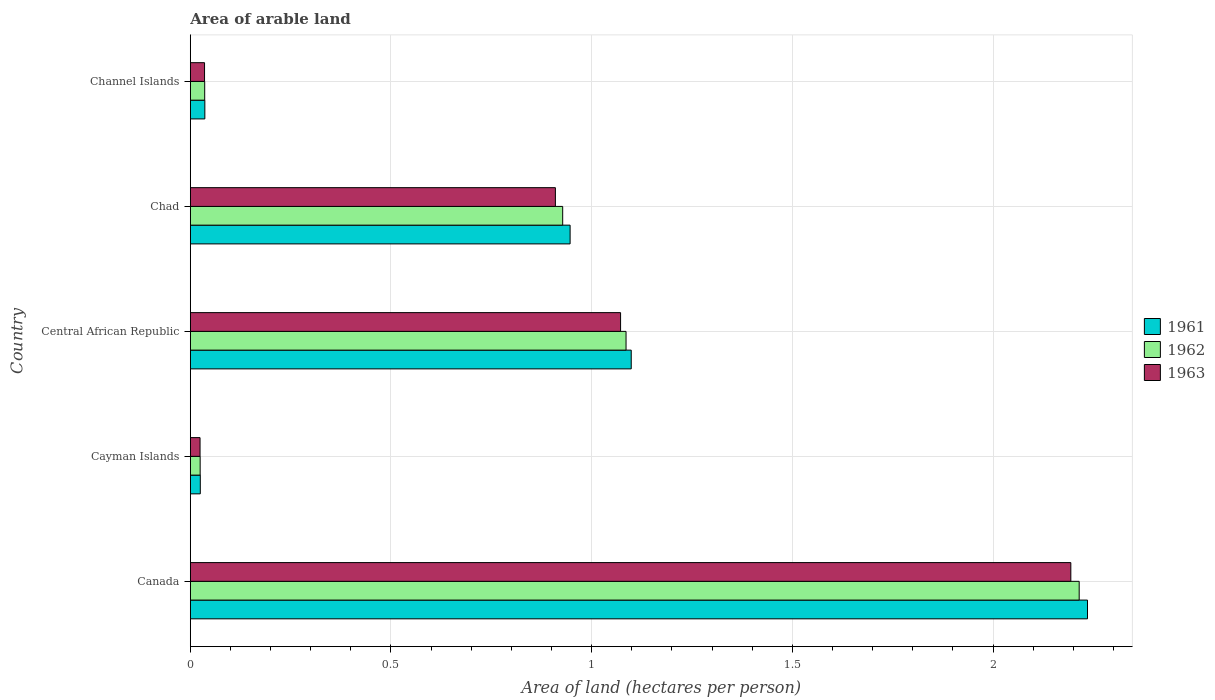Are the number of bars per tick equal to the number of legend labels?
Give a very brief answer. Yes. What is the label of the 4th group of bars from the top?
Your response must be concise. Cayman Islands. What is the total arable land in 1962 in Canada?
Provide a succinct answer. 2.21. Across all countries, what is the maximum total arable land in 1961?
Your answer should be very brief. 2.24. Across all countries, what is the minimum total arable land in 1962?
Your response must be concise. 0.02. In which country was the total arable land in 1962 minimum?
Ensure brevity in your answer.  Cayman Islands. What is the total total arable land in 1962 in the graph?
Provide a succinct answer. 4.29. What is the difference between the total arable land in 1961 in Canada and that in Central African Republic?
Provide a short and direct response. 1.14. What is the difference between the total arable land in 1962 in Central African Republic and the total arable land in 1963 in Canada?
Give a very brief answer. -1.11. What is the average total arable land in 1961 per country?
Make the answer very short. 0.87. What is the difference between the total arable land in 1961 and total arable land in 1962 in Channel Islands?
Your answer should be very brief. 0. In how many countries, is the total arable land in 1961 greater than 1.2 hectares per person?
Ensure brevity in your answer.  1. What is the ratio of the total arable land in 1963 in Cayman Islands to that in Chad?
Your answer should be compact. 0.03. Is the difference between the total arable land in 1961 in Cayman Islands and Channel Islands greater than the difference between the total arable land in 1962 in Cayman Islands and Channel Islands?
Your answer should be very brief. Yes. What is the difference between the highest and the second highest total arable land in 1962?
Give a very brief answer. 1.13. What is the difference between the highest and the lowest total arable land in 1962?
Offer a very short reply. 2.19. How many bars are there?
Your answer should be very brief. 15. What is the difference between two consecutive major ticks on the X-axis?
Keep it short and to the point. 0.5. Are the values on the major ticks of X-axis written in scientific E-notation?
Provide a succinct answer. No. Does the graph contain any zero values?
Your answer should be compact. No. Where does the legend appear in the graph?
Provide a short and direct response. Center right. How many legend labels are there?
Offer a very short reply. 3. What is the title of the graph?
Offer a terse response. Area of arable land. Does "1966" appear as one of the legend labels in the graph?
Give a very brief answer. No. What is the label or title of the X-axis?
Offer a terse response. Area of land (hectares per person). What is the Area of land (hectares per person) of 1961 in Canada?
Give a very brief answer. 2.24. What is the Area of land (hectares per person) in 1962 in Canada?
Your response must be concise. 2.21. What is the Area of land (hectares per person) in 1963 in Canada?
Make the answer very short. 2.19. What is the Area of land (hectares per person) of 1961 in Cayman Islands?
Offer a very short reply. 0.02. What is the Area of land (hectares per person) of 1962 in Cayman Islands?
Offer a very short reply. 0.02. What is the Area of land (hectares per person) in 1963 in Cayman Islands?
Make the answer very short. 0.02. What is the Area of land (hectares per person) in 1961 in Central African Republic?
Your answer should be very brief. 1.1. What is the Area of land (hectares per person) of 1962 in Central African Republic?
Ensure brevity in your answer.  1.09. What is the Area of land (hectares per person) of 1963 in Central African Republic?
Ensure brevity in your answer.  1.07. What is the Area of land (hectares per person) of 1961 in Chad?
Your response must be concise. 0.95. What is the Area of land (hectares per person) of 1962 in Chad?
Your response must be concise. 0.93. What is the Area of land (hectares per person) in 1963 in Chad?
Your response must be concise. 0.91. What is the Area of land (hectares per person) in 1961 in Channel Islands?
Keep it short and to the point. 0.04. What is the Area of land (hectares per person) in 1962 in Channel Islands?
Make the answer very short. 0.04. What is the Area of land (hectares per person) of 1963 in Channel Islands?
Your answer should be compact. 0.04. Across all countries, what is the maximum Area of land (hectares per person) in 1961?
Make the answer very short. 2.24. Across all countries, what is the maximum Area of land (hectares per person) of 1962?
Offer a terse response. 2.21. Across all countries, what is the maximum Area of land (hectares per person) of 1963?
Your answer should be compact. 2.19. Across all countries, what is the minimum Area of land (hectares per person) in 1961?
Make the answer very short. 0.02. Across all countries, what is the minimum Area of land (hectares per person) in 1962?
Your response must be concise. 0.02. Across all countries, what is the minimum Area of land (hectares per person) of 1963?
Offer a terse response. 0.02. What is the total Area of land (hectares per person) in 1961 in the graph?
Your response must be concise. 4.34. What is the total Area of land (hectares per person) in 1962 in the graph?
Ensure brevity in your answer.  4.29. What is the total Area of land (hectares per person) of 1963 in the graph?
Ensure brevity in your answer.  4.24. What is the difference between the Area of land (hectares per person) in 1961 in Canada and that in Cayman Islands?
Make the answer very short. 2.21. What is the difference between the Area of land (hectares per person) of 1962 in Canada and that in Cayman Islands?
Your answer should be compact. 2.19. What is the difference between the Area of land (hectares per person) in 1963 in Canada and that in Cayman Islands?
Offer a very short reply. 2.17. What is the difference between the Area of land (hectares per person) of 1961 in Canada and that in Central African Republic?
Keep it short and to the point. 1.14. What is the difference between the Area of land (hectares per person) of 1962 in Canada and that in Central African Republic?
Give a very brief answer. 1.13. What is the difference between the Area of land (hectares per person) of 1963 in Canada and that in Central African Republic?
Keep it short and to the point. 1.12. What is the difference between the Area of land (hectares per person) in 1961 in Canada and that in Chad?
Give a very brief answer. 1.29. What is the difference between the Area of land (hectares per person) in 1962 in Canada and that in Chad?
Offer a very short reply. 1.29. What is the difference between the Area of land (hectares per person) in 1963 in Canada and that in Chad?
Keep it short and to the point. 1.28. What is the difference between the Area of land (hectares per person) of 1961 in Canada and that in Channel Islands?
Provide a succinct answer. 2.2. What is the difference between the Area of land (hectares per person) in 1962 in Canada and that in Channel Islands?
Your response must be concise. 2.18. What is the difference between the Area of land (hectares per person) of 1963 in Canada and that in Channel Islands?
Your answer should be compact. 2.16. What is the difference between the Area of land (hectares per person) in 1961 in Cayman Islands and that in Central African Republic?
Your response must be concise. -1.07. What is the difference between the Area of land (hectares per person) in 1962 in Cayman Islands and that in Central African Republic?
Give a very brief answer. -1.06. What is the difference between the Area of land (hectares per person) in 1963 in Cayman Islands and that in Central African Republic?
Provide a succinct answer. -1.05. What is the difference between the Area of land (hectares per person) in 1961 in Cayman Islands and that in Chad?
Offer a very short reply. -0.92. What is the difference between the Area of land (hectares per person) in 1962 in Cayman Islands and that in Chad?
Your response must be concise. -0.9. What is the difference between the Area of land (hectares per person) in 1963 in Cayman Islands and that in Chad?
Your answer should be very brief. -0.89. What is the difference between the Area of land (hectares per person) of 1961 in Cayman Islands and that in Channel Islands?
Your response must be concise. -0.01. What is the difference between the Area of land (hectares per person) in 1962 in Cayman Islands and that in Channel Islands?
Your answer should be very brief. -0.01. What is the difference between the Area of land (hectares per person) in 1963 in Cayman Islands and that in Channel Islands?
Give a very brief answer. -0.01. What is the difference between the Area of land (hectares per person) in 1961 in Central African Republic and that in Chad?
Provide a succinct answer. 0.15. What is the difference between the Area of land (hectares per person) of 1962 in Central African Republic and that in Chad?
Offer a very short reply. 0.16. What is the difference between the Area of land (hectares per person) of 1963 in Central African Republic and that in Chad?
Give a very brief answer. 0.16. What is the difference between the Area of land (hectares per person) in 1961 in Central African Republic and that in Channel Islands?
Give a very brief answer. 1.06. What is the difference between the Area of land (hectares per person) of 1962 in Central African Republic and that in Channel Islands?
Give a very brief answer. 1.05. What is the difference between the Area of land (hectares per person) in 1963 in Central African Republic and that in Channel Islands?
Your answer should be compact. 1.04. What is the difference between the Area of land (hectares per person) of 1961 in Chad and that in Channel Islands?
Your response must be concise. 0.91. What is the difference between the Area of land (hectares per person) in 1962 in Chad and that in Channel Islands?
Your answer should be compact. 0.89. What is the difference between the Area of land (hectares per person) in 1963 in Chad and that in Channel Islands?
Your response must be concise. 0.87. What is the difference between the Area of land (hectares per person) of 1961 in Canada and the Area of land (hectares per person) of 1962 in Cayman Islands?
Ensure brevity in your answer.  2.21. What is the difference between the Area of land (hectares per person) in 1961 in Canada and the Area of land (hectares per person) in 1963 in Cayman Islands?
Your answer should be very brief. 2.21. What is the difference between the Area of land (hectares per person) in 1962 in Canada and the Area of land (hectares per person) in 1963 in Cayman Islands?
Keep it short and to the point. 2.19. What is the difference between the Area of land (hectares per person) in 1961 in Canada and the Area of land (hectares per person) in 1962 in Central African Republic?
Offer a terse response. 1.15. What is the difference between the Area of land (hectares per person) of 1961 in Canada and the Area of land (hectares per person) of 1963 in Central African Republic?
Your response must be concise. 1.16. What is the difference between the Area of land (hectares per person) of 1962 in Canada and the Area of land (hectares per person) of 1963 in Central African Republic?
Provide a short and direct response. 1.14. What is the difference between the Area of land (hectares per person) of 1961 in Canada and the Area of land (hectares per person) of 1962 in Chad?
Your answer should be very brief. 1.31. What is the difference between the Area of land (hectares per person) of 1961 in Canada and the Area of land (hectares per person) of 1963 in Chad?
Your answer should be compact. 1.33. What is the difference between the Area of land (hectares per person) in 1962 in Canada and the Area of land (hectares per person) in 1963 in Chad?
Offer a very short reply. 1.3. What is the difference between the Area of land (hectares per person) in 1961 in Canada and the Area of land (hectares per person) in 1962 in Channel Islands?
Your answer should be very brief. 2.2. What is the difference between the Area of land (hectares per person) of 1961 in Canada and the Area of land (hectares per person) of 1963 in Channel Islands?
Ensure brevity in your answer.  2.2. What is the difference between the Area of land (hectares per person) in 1962 in Canada and the Area of land (hectares per person) in 1963 in Channel Islands?
Provide a short and direct response. 2.18. What is the difference between the Area of land (hectares per person) of 1961 in Cayman Islands and the Area of land (hectares per person) of 1962 in Central African Republic?
Your response must be concise. -1.06. What is the difference between the Area of land (hectares per person) of 1961 in Cayman Islands and the Area of land (hectares per person) of 1963 in Central African Republic?
Your answer should be very brief. -1.05. What is the difference between the Area of land (hectares per person) of 1962 in Cayman Islands and the Area of land (hectares per person) of 1963 in Central African Republic?
Ensure brevity in your answer.  -1.05. What is the difference between the Area of land (hectares per person) in 1961 in Cayman Islands and the Area of land (hectares per person) in 1962 in Chad?
Your response must be concise. -0.9. What is the difference between the Area of land (hectares per person) in 1961 in Cayman Islands and the Area of land (hectares per person) in 1963 in Chad?
Your answer should be very brief. -0.88. What is the difference between the Area of land (hectares per person) of 1962 in Cayman Islands and the Area of land (hectares per person) of 1963 in Chad?
Your response must be concise. -0.89. What is the difference between the Area of land (hectares per person) in 1961 in Cayman Islands and the Area of land (hectares per person) in 1962 in Channel Islands?
Provide a succinct answer. -0.01. What is the difference between the Area of land (hectares per person) in 1961 in Cayman Islands and the Area of land (hectares per person) in 1963 in Channel Islands?
Ensure brevity in your answer.  -0.01. What is the difference between the Area of land (hectares per person) in 1962 in Cayman Islands and the Area of land (hectares per person) in 1963 in Channel Islands?
Your answer should be very brief. -0.01. What is the difference between the Area of land (hectares per person) of 1961 in Central African Republic and the Area of land (hectares per person) of 1962 in Chad?
Make the answer very short. 0.17. What is the difference between the Area of land (hectares per person) of 1961 in Central African Republic and the Area of land (hectares per person) of 1963 in Chad?
Your response must be concise. 0.19. What is the difference between the Area of land (hectares per person) of 1962 in Central African Republic and the Area of land (hectares per person) of 1963 in Chad?
Provide a succinct answer. 0.18. What is the difference between the Area of land (hectares per person) of 1961 in Central African Republic and the Area of land (hectares per person) of 1962 in Channel Islands?
Offer a terse response. 1.06. What is the difference between the Area of land (hectares per person) in 1961 in Central African Republic and the Area of land (hectares per person) in 1963 in Channel Islands?
Your response must be concise. 1.06. What is the difference between the Area of land (hectares per person) of 1962 in Central African Republic and the Area of land (hectares per person) of 1963 in Channel Islands?
Your answer should be compact. 1.05. What is the difference between the Area of land (hectares per person) in 1961 in Chad and the Area of land (hectares per person) in 1962 in Channel Islands?
Keep it short and to the point. 0.91. What is the difference between the Area of land (hectares per person) in 1961 in Chad and the Area of land (hectares per person) in 1963 in Channel Islands?
Your answer should be compact. 0.91. What is the difference between the Area of land (hectares per person) in 1962 in Chad and the Area of land (hectares per person) in 1963 in Channel Islands?
Your response must be concise. 0.89. What is the average Area of land (hectares per person) of 1961 per country?
Provide a succinct answer. 0.87. What is the average Area of land (hectares per person) in 1962 per country?
Ensure brevity in your answer.  0.86. What is the average Area of land (hectares per person) in 1963 per country?
Offer a very short reply. 0.85. What is the difference between the Area of land (hectares per person) in 1961 and Area of land (hectares per person) in 1962 in Canada?
Offer a terse response. 0.02. What is the difference between the Area of land (hectares per person) of 1961 and Area of land (hectares per person) of 1963 in Canada?
Ensure brevity in your answer.  0.04. What is the difference between the Area of land (hectares per person) in 1962 and Area of land (hectares per person) in 1963 in Canada?
Provide a succinct answer. 0.02. What is the difference between the Area of land (hectares per person) of 1961 and Area of land (hectares per person) of 1963 in Cayman Islands?
Ensure brevity in your answer.  0. What is the difference between the Area of land (hectares per person) of 1961 and Area of land (hectares per person) of 1962 in Central African Republic?
Give a very brief answer. 0.01. What is the difference between the Area of land (hectares per person) of 1961 and Area of land (hectares per person) of 1963 in Central African Republic?
Provide a short and direct response. 0.03. What is the difference between the Area of land (hectares per person) of 1962 and Area of land (hectares per person) of 1963 in Central African Republic?
Offer a terse response. 0.01. What is the difference between the Area of land (hectares per person) in 1961 and Area of land (hectares per person) in 1962 in Chad?
Offer a very short reply. 0.02. What is the difference between the Area of land (hectares per person) in 1961 and Area of land (hectares per person) in 1963 in Chad?
Make the answer very short. 0.04. What is the difference between the Area of land (hectares per person) in 1962 and Area of land (hectares per person) in 1963 in Chad?
Make the answer very short. 0.02. What is the difference between the Area of land (hectares per person) in 1961 and Area of land (hectares per person) in 1962 in Channel Islands?
Your answer should be compact. 0. What is the difference between the Area of land (hectares per person) in 1961 and Area of land (hectares per person) in 1963 in Channel Islands?
Offer a terse response. 0. What is the ratio of the Area of land (hectares per person) in 1961 in Canada to that in Cayman Islands?
Offer a very short reply. 89.71. What is the ratio of the Area of land (hectares per person) in 1962 in Canada to that in Cayman Islands?
Keep it short and to the point. 90.16. What is the ratio of the Area of land (hectares per person) in 1963 in Canada to that in Cayman Islands?
Offer a terse response. 90.25. What is the ratio of the Area of land (hectares per person) in 1961 in Canada to that in Central African Republic?
Provide a short and direct response. 2.03. What is the ratio of the Area of land (hectares per person) of 1962 in Canada to that in Central African Republic?
Provide a succinct answer. 2.04. What is the ratio of the Area of land (hectares per person) of 1963 in Canada to that in Central African Republic?
Keep it short and to the point. 2.05. What is the ratio of the Area of land (hectares per person) of 1961 in Canada to that in Chad?
Make the answer very short. 2.36. What is the ratio of the Area of land (hectares per person) in 1962 in Canada to that in Chad?
Make the answer very short. 2.39. What is the ratio of the Area of land (hectares per person) in 1963 in Canada to that in Chad?
Provide a succinct answer. 2.41. What is the ratio of the Area of land (hectares per person) of 1961 in Canada to that in Channel Islands?
Offer a very short reply. 61.7. What is the ratio of the Area of land (hectares per person) of 1962 in Canada to that in Channel Islands?
Provide a short and direct response. 61.71. What is the ratio of the Area of land (hectares per person) in 1963 in Canada to that in Channel Islands?
Offer a terse response. 61.75. What is the ratio of the Area of land (hectares per person) of 1961 in Cayman Islands to that in Central African Republic?
Offer a terse response. 0.02. What is the ratio of the Area of land (hectares per person) of 1962 in Cayman Islands to that in Central African Republic?
Offer a very short reply. 0.02. What is the ratio of the Area of land (hectares per person) of 1963 in Cayman Islands to that in Central African Republic?
Give a very brief answer. 0.02. What is the ratio of the Area of land (hectares per person) in 1961 in Cayman Islands to that in Chad?
Give a very brief answer. 0.03. What is the ratio of the Area of land (hectares per person) of 1962 in Cayman Islands to that in Chad?
Ensure brevity in your answer.  0.03. What is the ratio of the Area of land (hectares per person) of 1963 in Cayman Islands to that in Chad?
Make the answer very short. 0.03. What is the ratio of the Area of land (hectares per person) in 1961 in Cayman Islands to that in Channel Islands?
Ensure brevity in your answer.  0.69. What is the ratio of the Area of land (hectares per person) of 1962 in Cayman Islands to that in Channel Islands?
Ensure brevity in your answer.  0.68. What is the ratio of the Area of land (hectares per person) of 1963 in Cayman Islands to that in Channel Islands?
Make the answer very short. 0.68. What is the ratio of the Area of land (hectares per person) in 1961 in Central African Republic to that in Chad?
Keep it short and to the point. 1.16. What is the ratio of the Area of land (hectares per person) in 1962 in Central African Republic to that in Chad?
Offer a very short reply. 1.17. What is the ratio of the Area of land (hectares per person) of 1963 in Central African Republic to that in Chad?
Make the answer very short. 1.18. What is the ratio of the Area of land (hectares per person) in 1961 in Central African Republic to that in Channel Islands?
Make the answer very short. 30.32. What is the ratio of the Area of land (hectares per person) in 1962 in Central African Republic to that in Channel Islands?
Provide a succinct answer. 30.25. What is the ratio of the Area of land (hectares per person) of 1963 in Central African Republic to that in Channel Islands?
Keep it short and to the point. 30.18. What is the ratio of the Area of land (hectares per person) of 1961 in Chad to that in Channel Islands?
Make the answer very short. 26.12. What is the ratio of the Area of land (hectares per person) in 1962 in Chad to that in Channel Islands?
Your answer should be very brief. 25.85. What is the ratio of the Area of land (hectares per person) in 1963 in Chad to that in Channel Islands?
Your answer should be compact. 25.61. What is the difference between the highest and the second highest Area of land (hectares per person) in 1961?
Provide a succinct answer. 1.14. What is the difference between the highest and the second highest Area of land (hectares per person) of 1962?
Ensure brevity in your answer.  1.13. What is the difference between the highest and the second highest Area of land (hectares per person) of 1963?
Your answer should be compact. 1.12. What is the difference between the highest and the lowest Area of land (hectares per person) of 1961?
Keep it short and to the point. 2.21. What is the difference between the highest and the lowest Area of land (hectares per person) in 1962?
Make the answer very short. 2.19. What is the difference between the highest and the lowest Area of land (hectares per person) of 1963?
Make the answer very short. 2.17. 